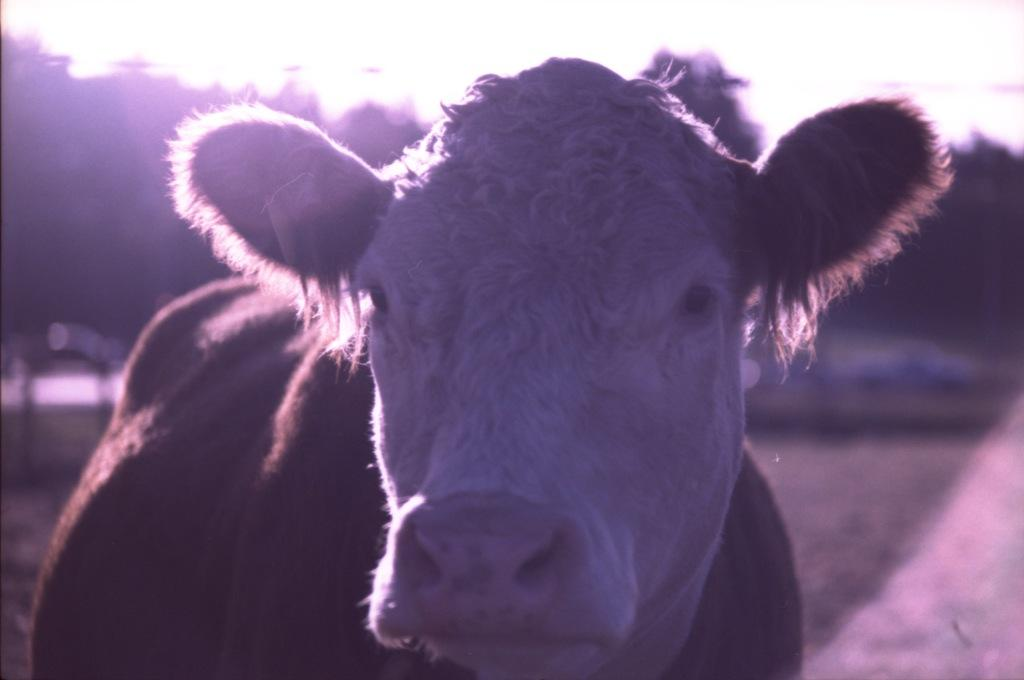What is the main subject in the foreground of the image? There is a cow in the foreground of the image. What can be seen in the background of the image? There are trees in the background of the image. What is visible at the top of the image? The sky is visible at the top of the image. Is there an alarm going off in the image? There is no alarm present in the image. Can you see any poisonous substances in the image? There is no mention of any poisonous substances in the image. 